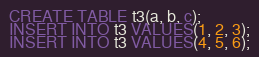<code> <loc_0><loc_0><loc_500><loc_500><_SQL_>CREATE TABLE t3(a, b, c);
INSERT INTO t3 VALUES(1, 2, 3);
INSERT INTO t3 VALUES(4, 5, 6);</code> 